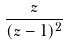<formula> <loc_0><loc_0><loc_500><loc_500>\frac { z } { ( z - 1 ) ^ { 2 } }</formula> 